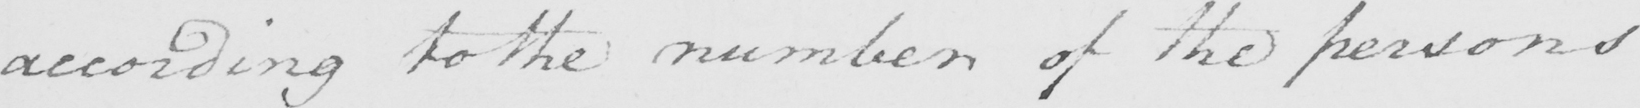Can you read and transcribe this handwriting? according to the number of the persons 